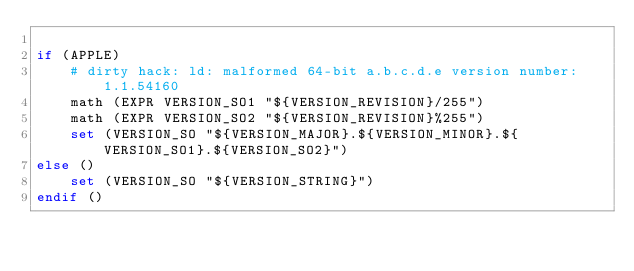<code> <loc_0><loc_0><loc_500><loc_500><_CMake_>
if (APPLE)
    # dirty hack: ld: malformed 64-bit a.b.c.d.e version number: 1.1.54160
    math (EXPR VERSION_SO1 "${VERSION_REVISION}/255")
    math (EXPR VERSION_SO2 "${VERSION_REVISION}%255")
    set (VERSION_SO "${VERSION_MAJOR}.${VERSION_MINOR}.${VERSION_SO1}.${VERSION_SO2}")
else ()
    set (VERSION_SO "${VERSION_STRING}")
endif ()
</code> 